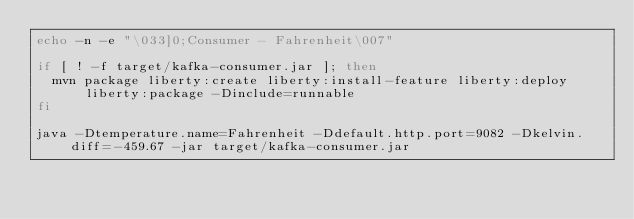<code> <loc_0><loc_0><loc_500><loc_500><_Bash_>echo -n -e "\033]0;Consumer - Fahrenheit\007"

if [ ! -f target/kafka-consumer.jar ]; then
  mvn package liberty:create liberty:install-feature liberty:deploy liberty:package -Dinclude=runnable
fi

java -Dtemperature.name=Fahrenheit -Ddefault.http.port=9082 -Dkelvin.diff=-459.67 -jar target/kafka-consumer.jar</code> 